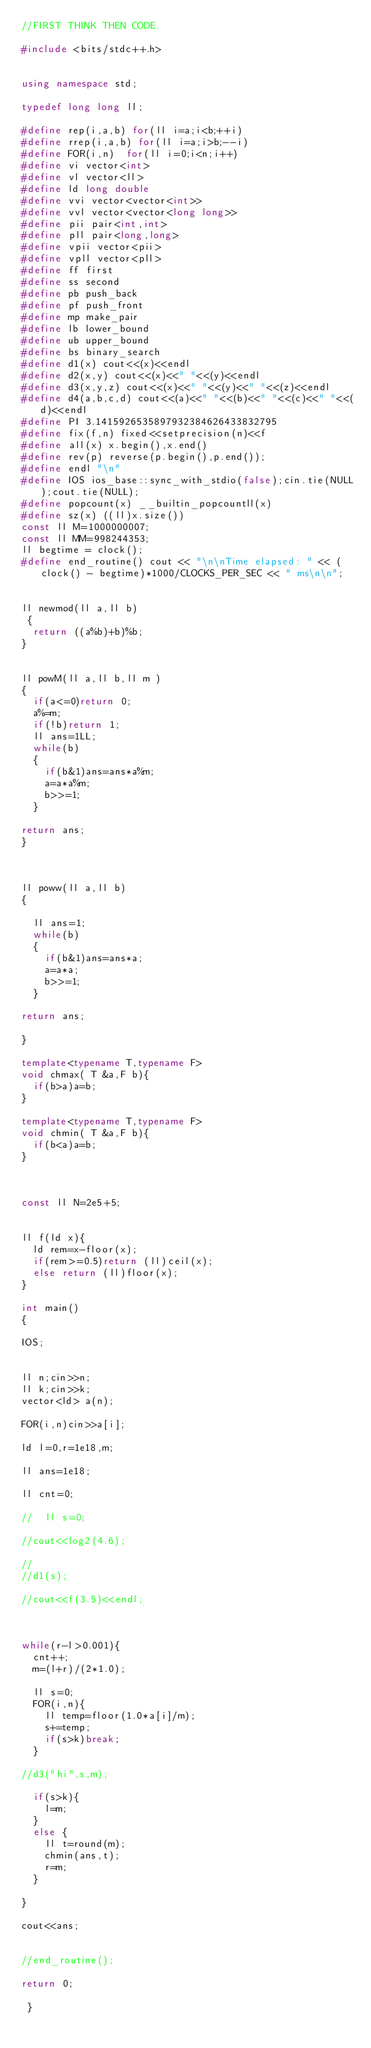<code> <loc_0><loc_0><loc_500><loc_500><_C++_>//FIRST THINK THEN CODE.

#include <bits/stdc++.h>
 
 
using namespace std;
 
typedef long long ll;
 
#define rep(i,a,b) for(ll i=a;i<b;++i)
#define rrep(i,a,b) for(ll i=a;i>b;--i)
#define FOR(i,n)  for(ll i=0;i<n;i++)
#define vi vector<int>
#define vl vector<ll>
#define ld long double
#define vvi vector<vector<int>>
#define vvl vector<vector<long long>>
#define pii pair<int,int>
#define pll pair<long,long>
#define vpii vector<pii>
#define vpll vector<pll>
#define ff first
#define ss second
#define pb push_back
#define pf push_front
#define mp make_pair
#define lb lower_bound
#define ub upper_bound
#define bs binary_search
#define d1(x) cout<<(x)<<endl
#define d2(x,y) cout<<(x)<<" "<<(y)<<endl
#define d3(x,y,z) cout<<(x)<<" "<<(y)<<" "<<(z)<<endl
#define d4(a,b,c,d) cout<<(a)<<" "<<(b)<<" "<<(c)<<" "<<(d)<<endl
#define PI 3.1415926535897932384626433832795
#define fix(f,n) fixed<<setprecision(n)<<f
#define all(x) x.begin(),x.end()
#define rev(p) reverse(p.begin(),p.end());
#define endl "\n"
#define IOS ios_base::sync_with_stdio(false);cin.tie(NULL);cout.tie(NULL);
#define popcount(x) __builtin_popcountll(x)
#define sz(x) ((ll)x.size())
const ll M=1000000007;
const ll MM=998244353;
ll begtime = clock();
#define end_routine() cout << "\n\nTime elapsed: " << (clock() - begtime)*1000/CLOCKS_PER_SEC << " ms\n\n";

 
ll newmod(ll a,ll b)
 {
  return ((a%b)+b)%b;
}
 
 
ll powM(ll a,ll b,ll m )
{ 
  if(a<=0)return 0;
  a%=m;
  if(!b)return 1;
  ll ans=1LL;
  while(b)
  {
    if(b&1)ans=ans*a%m;
    a=a*a%m;
    b>>=1;
  }
 
return ans;
}


 
ll poww(ll a,ll b)
{ 
  
  ll ans=1;
  while(b)
  {
    if(b&1)ans=ans*a;
    a=a*a;
    b>>=1;
  }
 
return ans;

}

template<typename T,typename F>
void chmax( T &a,F b){
  if(b>a)a=b;
}

template<typename T,typename F>
void chmin( T &a,F b){
  if(b<a)a=b;
}



const ll N=2e5+5;


ll f(ld x){
  ld rem=x-floor(x);
  if(rem>=0.5)return (ll)ceil(x);
  else return (ll)floor(x);
}

int main()
{ 

IOS;


ll n;cin>>n;
ll k;cin>>k;
vector<ld> a(n);

FOR(i,n)cin>>a[i];

ld l=0,r=1e18,m;

ll ans=1e18;

ll cnt=0;

//  ll s=0;

//cout<<log2(4.6);

//
//d1(s);

//cout<<f(3.5)<<endl;



while(r-l>0.001){
  cnt++;
  m=(l+r)/(2*1.0);

  ll s=0;
  FOR(i,n){
    ll temp=floor(1.0*a[i]/m);
    s+=temp;
    if(s>k)break;
  }

//d3("hi",s,m);

  if(s>k){
    l=m;
  }
  else {
    ll t=round(m);
    chmin(ans,t);
    r=m;
  }

}

cout<<ans;


//end_routine();

return 0;
 
 }
</code> 